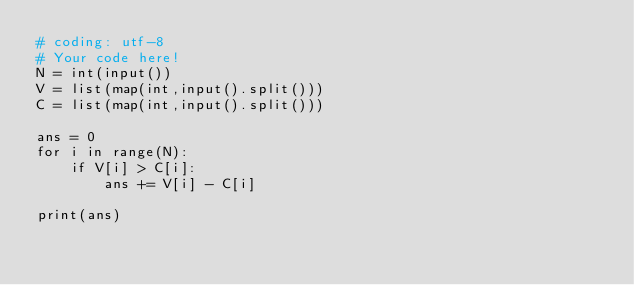Convert code to text. <code><loc_0><loc_0><loc_500><loc_500><_Python_># coding: utf-8
# Your code here!
N = int(input())
V = list(map(int,input().split()))
C = list(map(int,input().split()))

ans = 0
for i in range(N):
    if V[i] > C[i]:
        ans += V[i] - C[i]

print(ans)</code> 